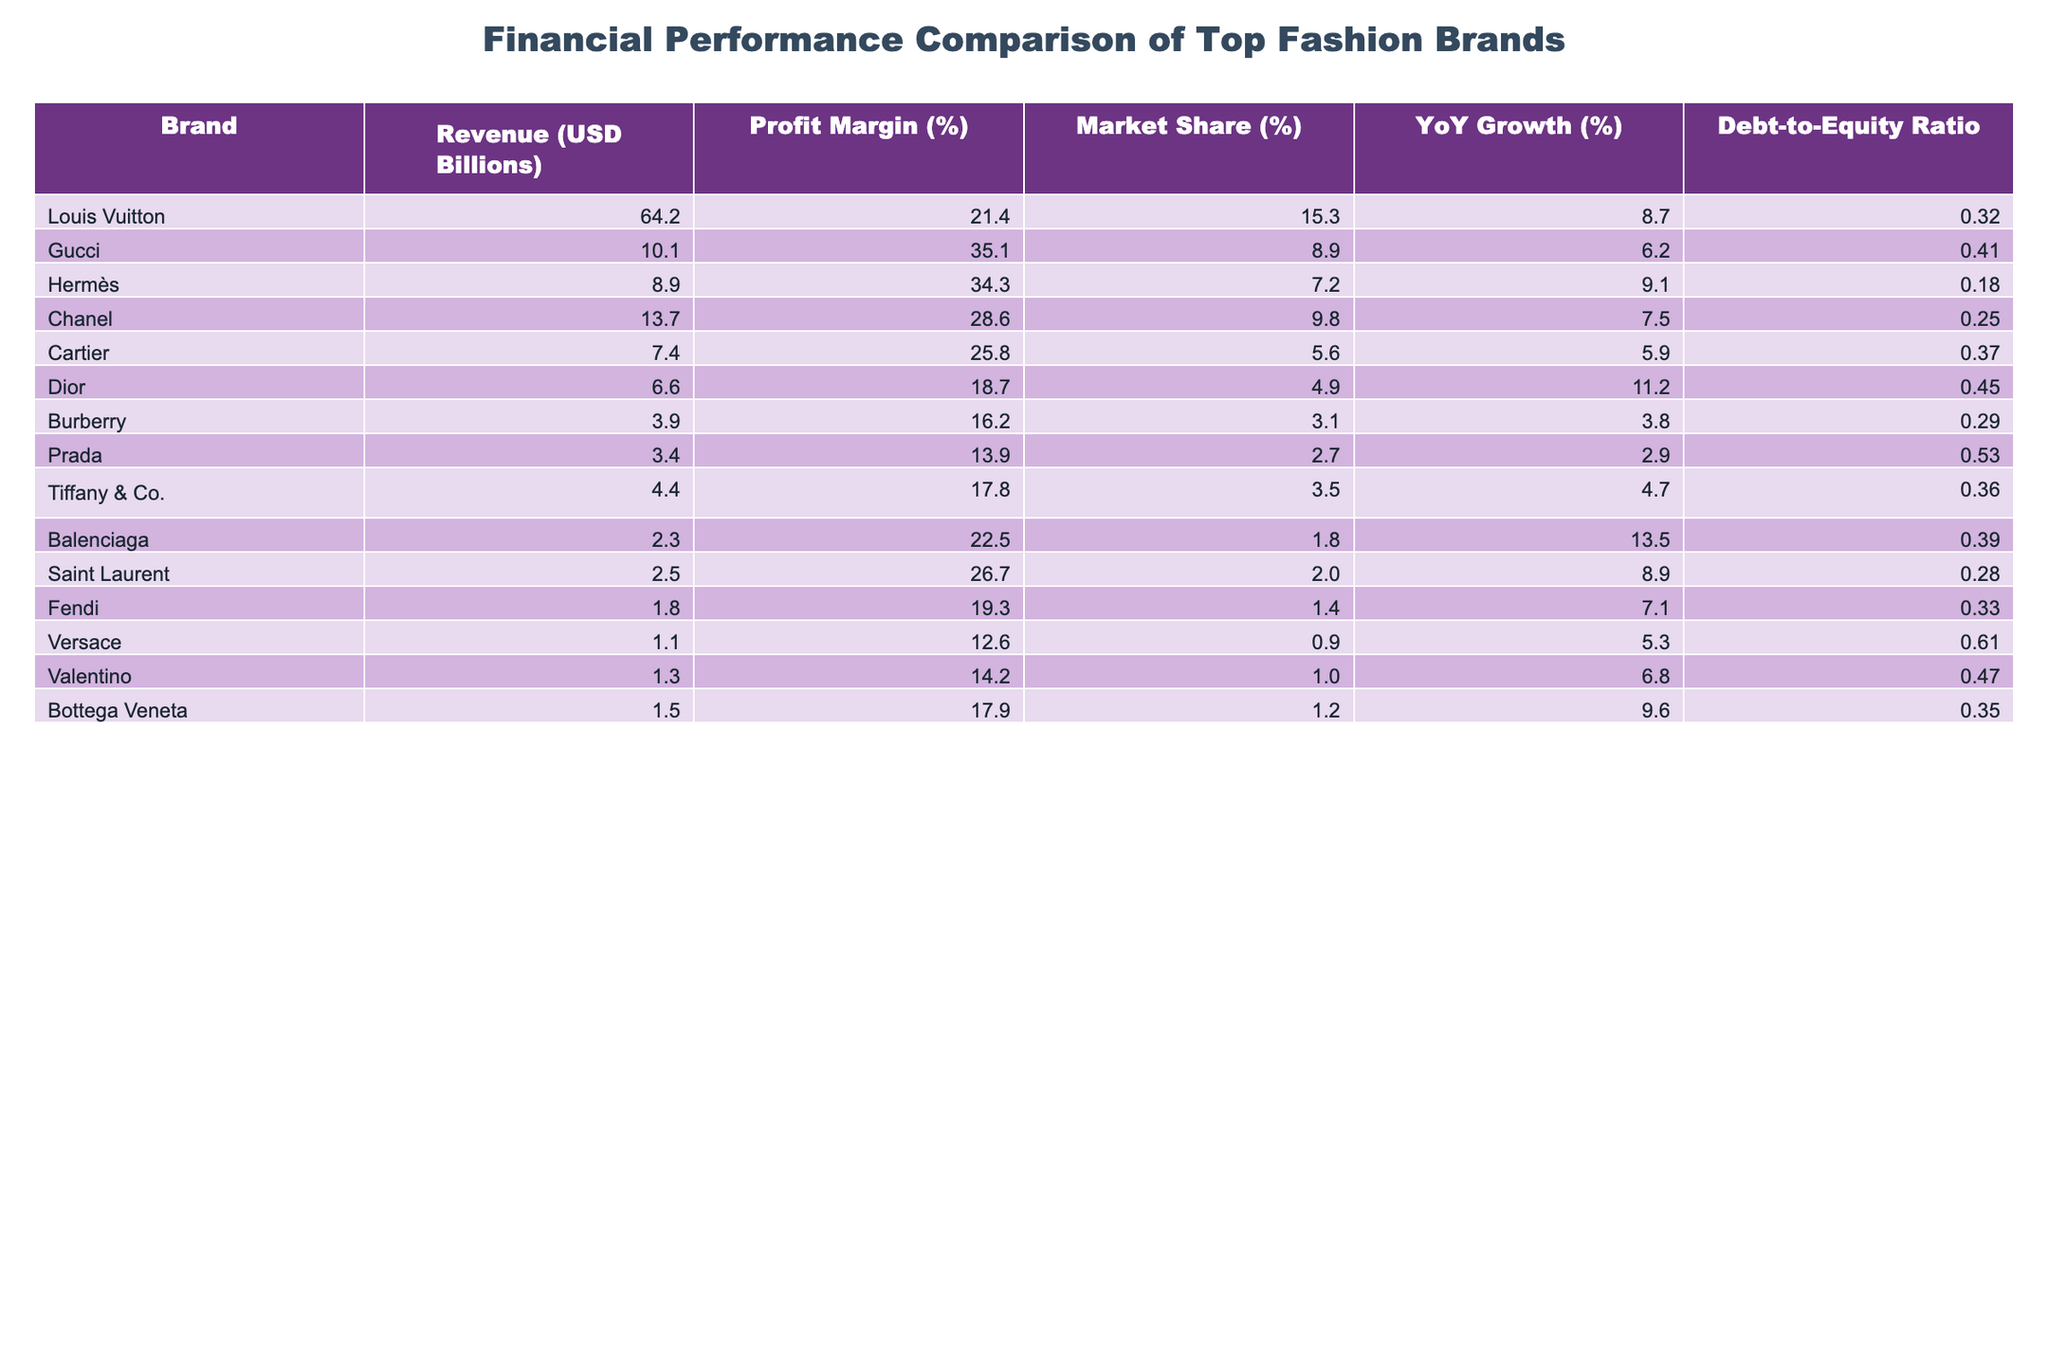What is the revenue of Louis Vuitton? Louis Vuitton's revenue is explicitly mentioned in the table as 64.2 billion USD.
Answer: 64.2 Billion USD Which brand has the highest profit margin? The table shows that Gucci has the highest profit margin at 35.1%.
Answer: Gucci What is the market share of Dior? According to the table, Dior has a market share of 4.9%.
Answer: 4.9% What is the average profit margin of the top three brands by revenue? The profit margins of the top three brands are 21.4% (Louis Vuitton), 35.1% (Gucci), and 34.3% (Hermès). The average is calculated as (21.4 + 35.1 + 34.3) / 3 = 30.30%.
Answer: 30.3% Which brand has a debt-to-equity ratio greater than 0.4? By examining the table, it shows that Gucci, Dior, Prada, and Versace have debt-to-equity ratios greater than 0.4 (0.41, 0.45, 0.53, and 0.61 respectively).
Answer: Yes Is the YoY growth for Chanel greater than the YoY growth for Burberry? The YoY growth for Chanel is 7.5% and for Burberry, it is 3.8%. Since 7.5% is greater than 3.8%, the statement is true.
Answer: Yes What is the difference in revenue between Gucci and Burberry? The revenue for Gucci is 10.1 billion USD and for Burberry is 3.9 billion USD. The difference is calculated as 10.1 - 3.9 = 6.2 billion USD.
Answer: 6.2 Billion USD Which brands have a profit margin below 20%? Referring to the table, Burberry (16.2%), Prada (13.9%), and Versace (12.6%) have profit margins below 20%.
Answer: Burberry, Prada, Versace What is the total revenue of the brands with lower than 5% market share? Brands with lower than 5% market share are Cartier (7.4 billion USD), Dior (6.6 billion USD), Burberry (3.9 billion USD), Prada (3.4 billion USD), Versace (1.1 billion USD), Valentino (1.3 billion USD), and Bottega Veneta (1.5 billion USD). Their total revenue is 7.4 + 6.6 + 3.9 + 3.4 + 1.1 + 1.3 + 1.5 = 25.2 billion USD.
Answer: 25.2 Billion USD Which brand has the highest YoY growth rate? The table displays that Balenciaga has the highest YoY growth rate at 13.5%.
Answer: Balenciaga 